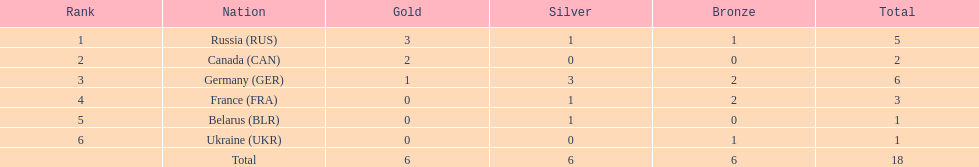What is the total number of silver medals won by belarus? 1. 